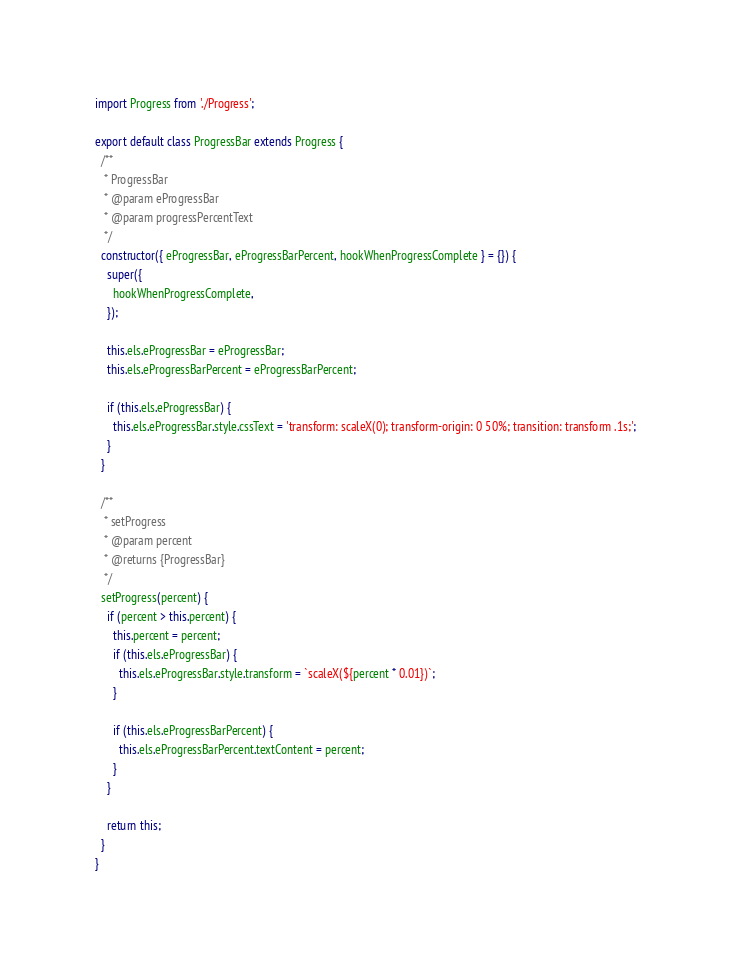Convert code to text. <code><loc_0><loc_0><loc_500><loc_500><_JavaScript_>import Progress from './Progress';

export default class ProgressBar extends Progress {
  /**
   * ProgressBar
   * @param eProgressBar
   * @param progressPercentText
   */
  constructor({ eProgressBar, eProgressBarPercent, hookWhenProgressComplete } = {}) {
    super({
      hookWhenProgressComplete,
    });

    this.els.eProgressBar = eProgressBar;
    this.els.eProgressBarPercent = eProgressBarPercent;

    if (this.els.eProgressBar) {
      this.els.eProgressBar.style.cssText = 'transform: scaleX(0); transform-origin: 0 50%; transition: transform .1s;';
    }
  }

  /**
   * setProgress
   * @param percent
   * @returns {ProgressBar}
   */
  setProgress(percent) {
    if (percent > this.percent) {
      this.percent = percent;
      if (this.els.eProgressBar) {
        this.els.eProgressBar.style.transform = `scaleX(${percent * 0.01})`;
      }

      if (this.els.eProgressBarPercent) {
        this.els.eProgressBarPercent.textContent = percent;
      }
    }

    return this;
  }
}
</code> 